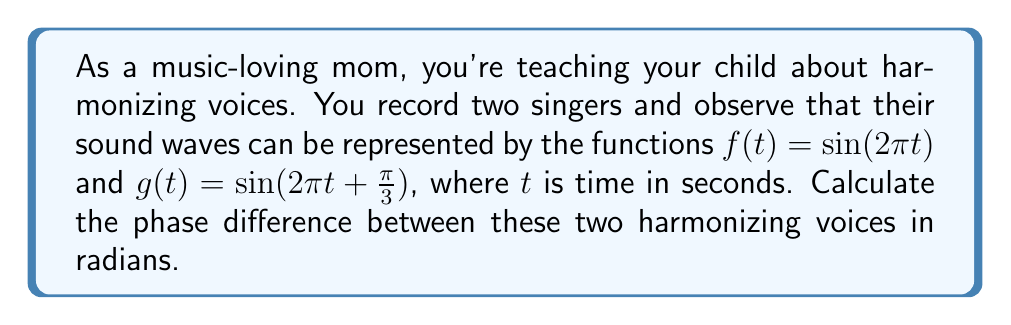Help me with this question. To find the phase difference between two sinusoidal functions, we need to compare their arguments. Let's break this down step-by-step:

1) The general form of a sine function is $\sin(2\pi ft + \phi)$, where $f$ is the frequency and $\phi$ is the phase shift.

2) For the first voice: $f(t) = \sin(2\pi t)$
   This is in the form $\sin(2\pi ft + \phi)$ with $f = 1$ and $\phi = 0$

3) For the second voice: $g(t) = \sin(2\pi t + \frac{\pi}{3})$
   This is in the form $\sin(2\pi ft + \phi)$ with $f = 1$ and $\phi = \frac{\pi}{3}$

4) The phase difference is the difference between these two phase shifts:
   $$\text{Phase difference} = \phi_2 - \phi_1 = \frac{\pi}{3} - 0 = \frac{\pi}{3}$$

Therefore, the phase difference between the two harmonizing voices is $\frac{\pi}{3}$ radians.
Answer: $\frac{\pi}{3}$ radians 